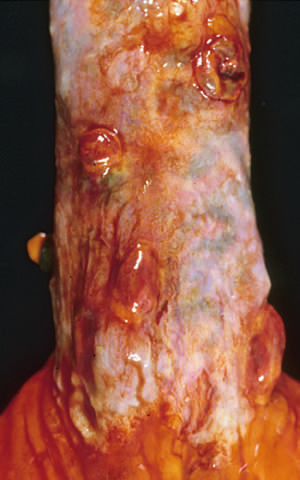what are the polypoid areas?
Answer the question using a single word or phrase. The sites of variceal hemorrhage that were ligated with bands 